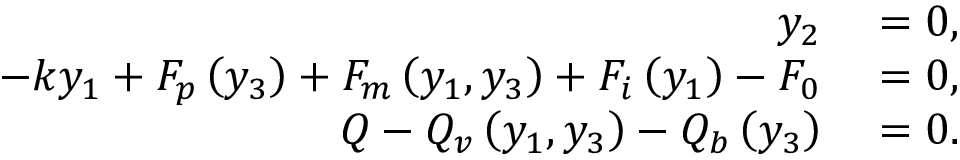<formula> <loc_0><loc_0><loc_500><loc_500>\begin{array} { r l } { y _ { 2 } } & = 0 , } \\ { - k y _ { 1 } + F _ { p } \left ( y _ { 3 } \right ) + F _ { m } \left ( y _ { 1 } , y _ { 3 } \right ) + F _ { i } \left ( y _ { 1 } \right ) - F _ { 0 } } & = 0 , } \\ { Q - Q _ { v } \left ( y _ { 1 } , y _ { 3 } \right ) - Q _ { b } \left ( y _ { 3 } \right ) } & = 0 . } \end{array}</formula> 